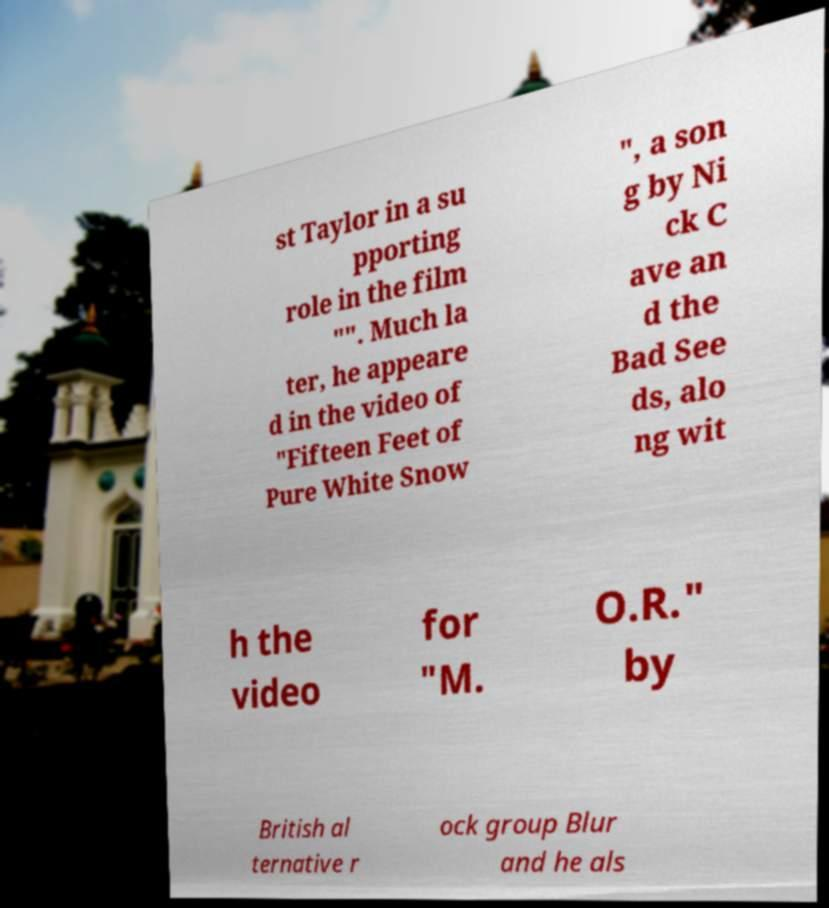Please read and relay the text visible in this image. What does it say? st Taylor in a su pporting role in the film "". Much la ter, he appeare d in the video of "Fifteen Feet of Pure White Snow ", a son g by Ni ck C ave an d the Bad See ds, alo ng wit h the video for "M. O.R." by British al ternative r ock group Blur and he als 